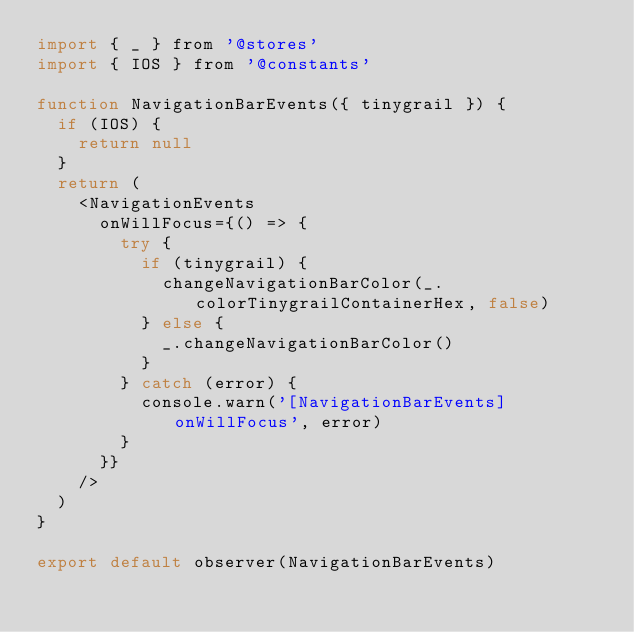<code> <loc_0><loc_0><loc_500><loc_500><_JavaScript_>import { _ } from '@stores'
import { IOS } from '@constants'

function NavigationBarEvents({ tinygrail }) {
  if (IOS) {
    return null
  }
  return (
    <NavigationEvents
      onWillFocus={() => {
        try {
          if (tinygrail) {
            changeNavigationBarColor(_.colorTinygrailContainerHex, false)
          } else {
            _.changeNavigationBarColor()
          }
        } catch (error) {
          console.warn('[NavigationBarEvents] onWillFocus', error)
        }
      }}
    />
  )
}

export default observer(NavigationBarEvents)
</code> 